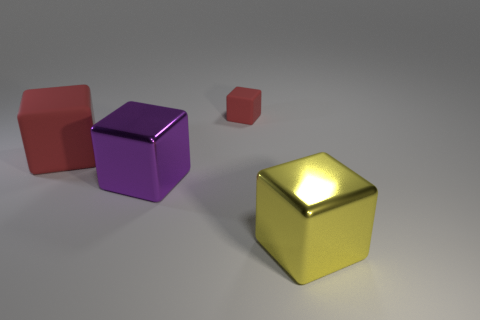There is a red thing on the right side of the thing that is to the left of the large purple thing; what is its size?
Offer a very short reply. Small. There is another large shiny object that is the same shape as the large purple object; what is its color?
Provide a succinct answer. Yellow. Do the purple block and the yellow shiny cube have the same size?
Provide a short and direct response. Yes. Are there an equal number of big yellow metallic blocks behind the small cube and metallic things?
Provide a succinct answer. No. Are there any big yellow metal cubes that are left of the large shiny block on the left side of the yellow metal block?
Provide a short and direct response. No. What is the size of the metal thing that is behind the yellow cube that is on the right side of the big metal object behind the large yellow metallic thing?
Provide a short and direct response. Large. Are there the same number of small red cubes and big green rubber objects?
Provide a short and direct response. No. What material is the block on the right side of the red thing that is on the right side of the large red matte cube?
Provide a short and direct response. Metal. Are there any large gray objects of the same shape as the big purple object?
Provide a succinct answer. No. What shape is the big matte thing?
Your answer should be very brief. Cube. 